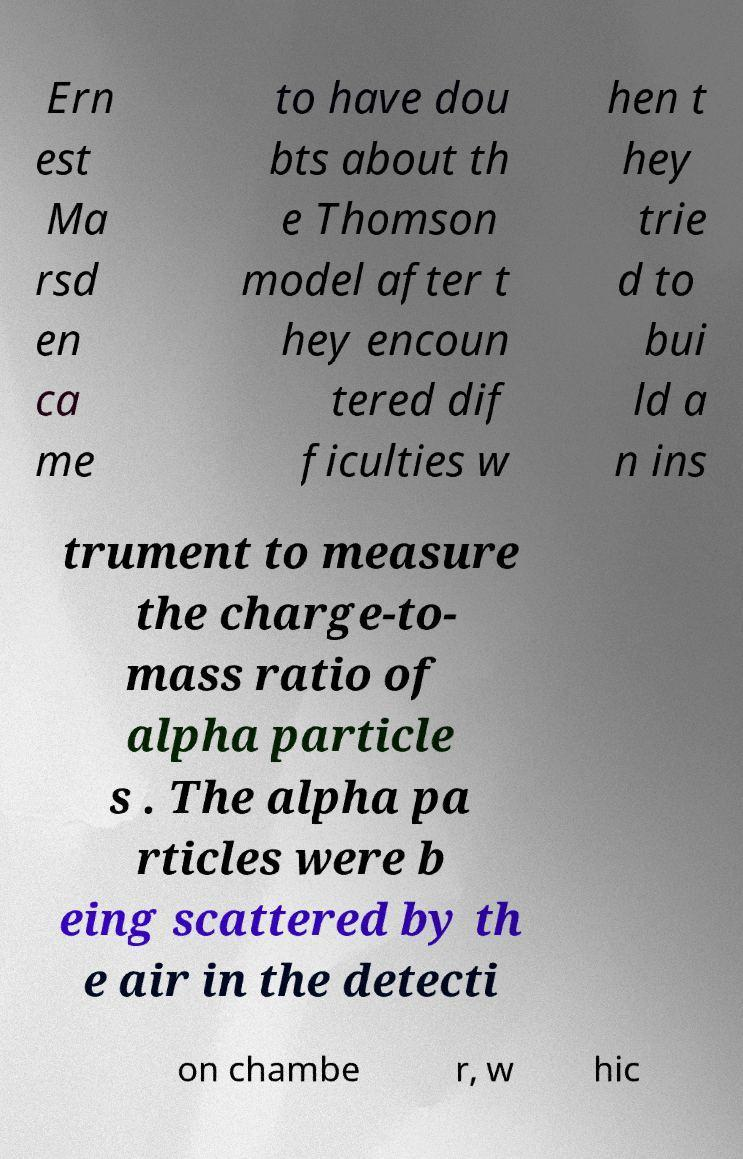What messages or text are displayed in this image? I need them in a readable, typed format. Ern est Ma rsd en ca me to have dou bts about th e Thomson model after t hey encoun tered dif ficulties w hen t hey trie d to bui ld a n ins trument to measure the charge-to- mass ratio of alpha particle s . The alpha pa rticles were b eing scattered by th e air in the detecti on chambe r, w hic 